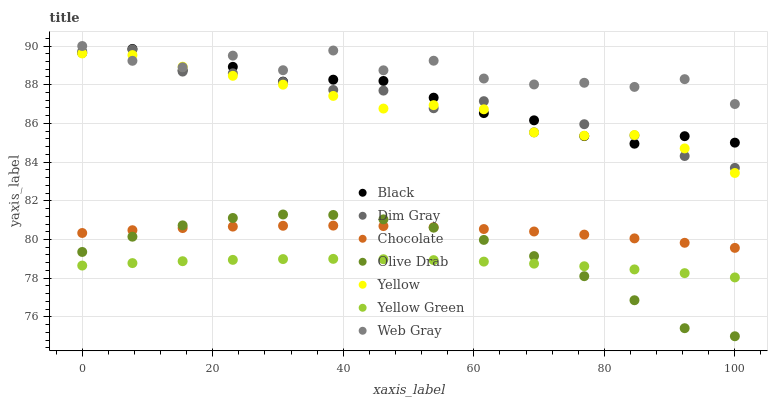Does Yellow Green have the minimum area under the curve?
Answer yes or no. Yes. Does Web Gray have the maximum area under the curve?
Answer yes or no. Yes. Does Yellow have the minimum area under the curve?
Answer yes or no. No. Does Yellow have the maximum area under the curve?
Answer yes or no. No. Is Yellow Green the smoothest?
Answer yes or no. Yes. Is Web Gray the roughest?
Answer yes or no. Yes. Is Yellow the smoothest?
Answer yes or no. No. Is Yellow the roughest?
Answer yes or no. No. Does Olive Drab have the lowest value?
Answer yes or no. Yes. Does Yellow Green have the lowest value?
Answer yes or no. No. Does Web Gray have the highest value?
Answer yes or no. Yes. Does Yellow have the highest value?
Answer yes or no. No. Is Yellow Green less than Dim Gray?
Answer yes or no. Yes. Is Dim Gray greater than Yellow Green?
Answer yes or no. Yes. Does Web Gray intersect Yellow?
Answer yes or no. Yes. Is Web Gray less than Yellow?
Answer yes or no. No. Is Web Gray greater than Yellow?
Answer yes or no. No. Does Yellow Green intersect Dim Gray?
Answer yes or no. No. 